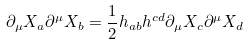<formula> <loc_0><loc_0><loc_500><loc_500>\partial _ { \mu } X _ { a } \partial ^ { \mu } X _ { b } = \frac { 1 } { 2 } h _ { a b } h ^ { c d } \partial _ { \mu } X _ { c } \partial ^ { \mu } X _ { d }</formula> 